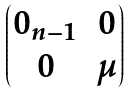<formula> <loc_0><loc_0><loc_500><loc_500>\begin{pmatrix} 0 _ { n - 1 } & 0 \\ 0 & \mu \end{pmatrix}</formula> 